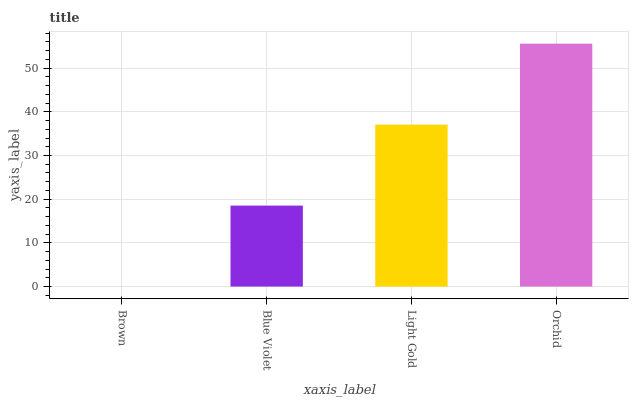Is Brown the minimum?
Answer yes or no. Yes. Is Orchid the maximum?
Answer yes or no. Yes. Is Blue Violet the minimum?
Answer yes or no. No. Is Blue Violet the maximum?
Answer yes or no. No. Is Blue Violet greater than Brown?
Answer yes or no. Yes. Is Brown less than Blue Violet?
Answer yes or no. Yes. Is Brown greater than Blue Violet?
Answer yes or no. No. Is Blue Violet less than Brown?
Answer yes or no. No. Is Light Gold the high median?
Answer yes or no. Yes. Is Blue Violet the low median?
Answer yes or no. Yes. Is Brown the high median?
Answer yes or no. No. Is Orchid the low median?
Answer yes or no. No. 